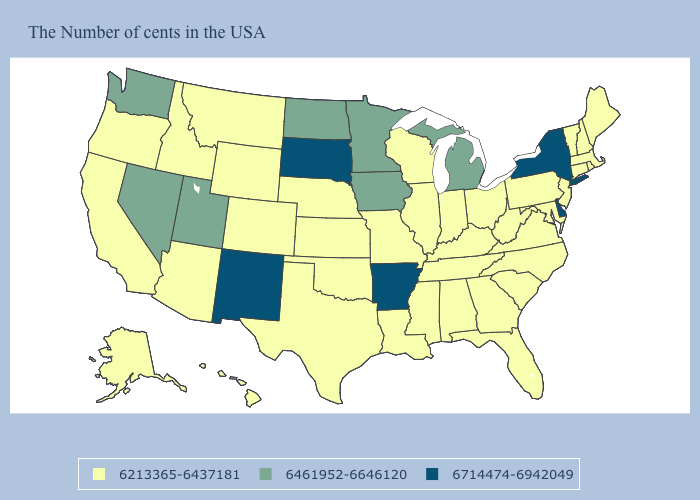What is the lowest value in the USA?
Give a very brief answer. 6213365-6437181. Does the first symbol in the legend represent the smallest category?
Concise answer only. Yes. Does New Mexico have the highest value in the West?
Keep it brief. Yes. Name the states that have a value in the range 6213365-6437181?
Concise answer only. Maine, Massachusetts, Rhode Island, New Hampshire, Vermont, Connecticut, New Jersey, Maryland, Pennsylvania, Virginia, North Carolina, South Carolina, West Virginia, Ohio, Florida, Georgia, Kentucky, Indiana, Alabama, Tennessee, Wisconsin, Illinois, Mississippi, Louisiana, Missouri, Kansas, Nebraska, Oklahoma, Texas, Wyoming, Colorado, Montana, Arizona, Idaho, California, Oregon, Alaska, Hawaii. Does South Dakota have the highest value in the USA?
Quick response, please. Yes. Name the states that have a value in the range 6213365-6437181?
Answer briefly. Maine, Massachusetts, Rhode Island, New Hampshire, Vermont, Connecticut, New Jersey, Maryland, Pennsylvania, Virginia, North Carolina, South Carolina, West Virginia, Ohio, Florida, Georgia, Kentucky, Indiana, Alabama, Tennessee, Wisconsin, Illinois, Mississippi, Louisiana, Missouri, Kansas, Nebraska, Oklahoma, Texas, Wyoming, Colorado, Montana, Arizona, Idaho, California, Oregon, Alaska, Hawaii. Name the states that have a value in the range 6213365-6437181?
Be succinct. Maine, Massachusetts, Rhode Island, New Hampshire, Vermont, Connecticut, New Jersey, Maryland, Pennsylvania, Virginia, North Carolina, South Carolina, West Virginia, Ohio, Florida, Georgia, Kentucky, Indiana, Alabama, Tennessee, Wisconsin, Illinois, Mississippi, Louisiana, Missouri, Kansas, Nebraska, Oklahoma, Texas, Wyoming, Colorado, Montana, Arizona, Idaho, California, Oregon, Alaska, Hawaii. Name the states that have a value in the range 6461952-6646120?
Give a very brief answer. Michigan, Minnesota, Iowa, North Dakota, Utah, Nevada, Washington. How many symbols are there in the legend?
Give a very brief answer. 3. Does New Mexico have the highest value in the West?
Write a very short answer. Yes. Does Alaska have the same value as West Virginia?
Write a very short answer. Yes. What is the value of South Carolina?
Write a very short answer. 6213365-6437181. Among the states that border Utah , which have the highest value?
Be succinct. New Mexico. Which states hav the highest value in the South?
Answer briefly. Delaware, Arkansas. Does Arkansas have the highest value in the USA?
Answer briefly. Yes. 